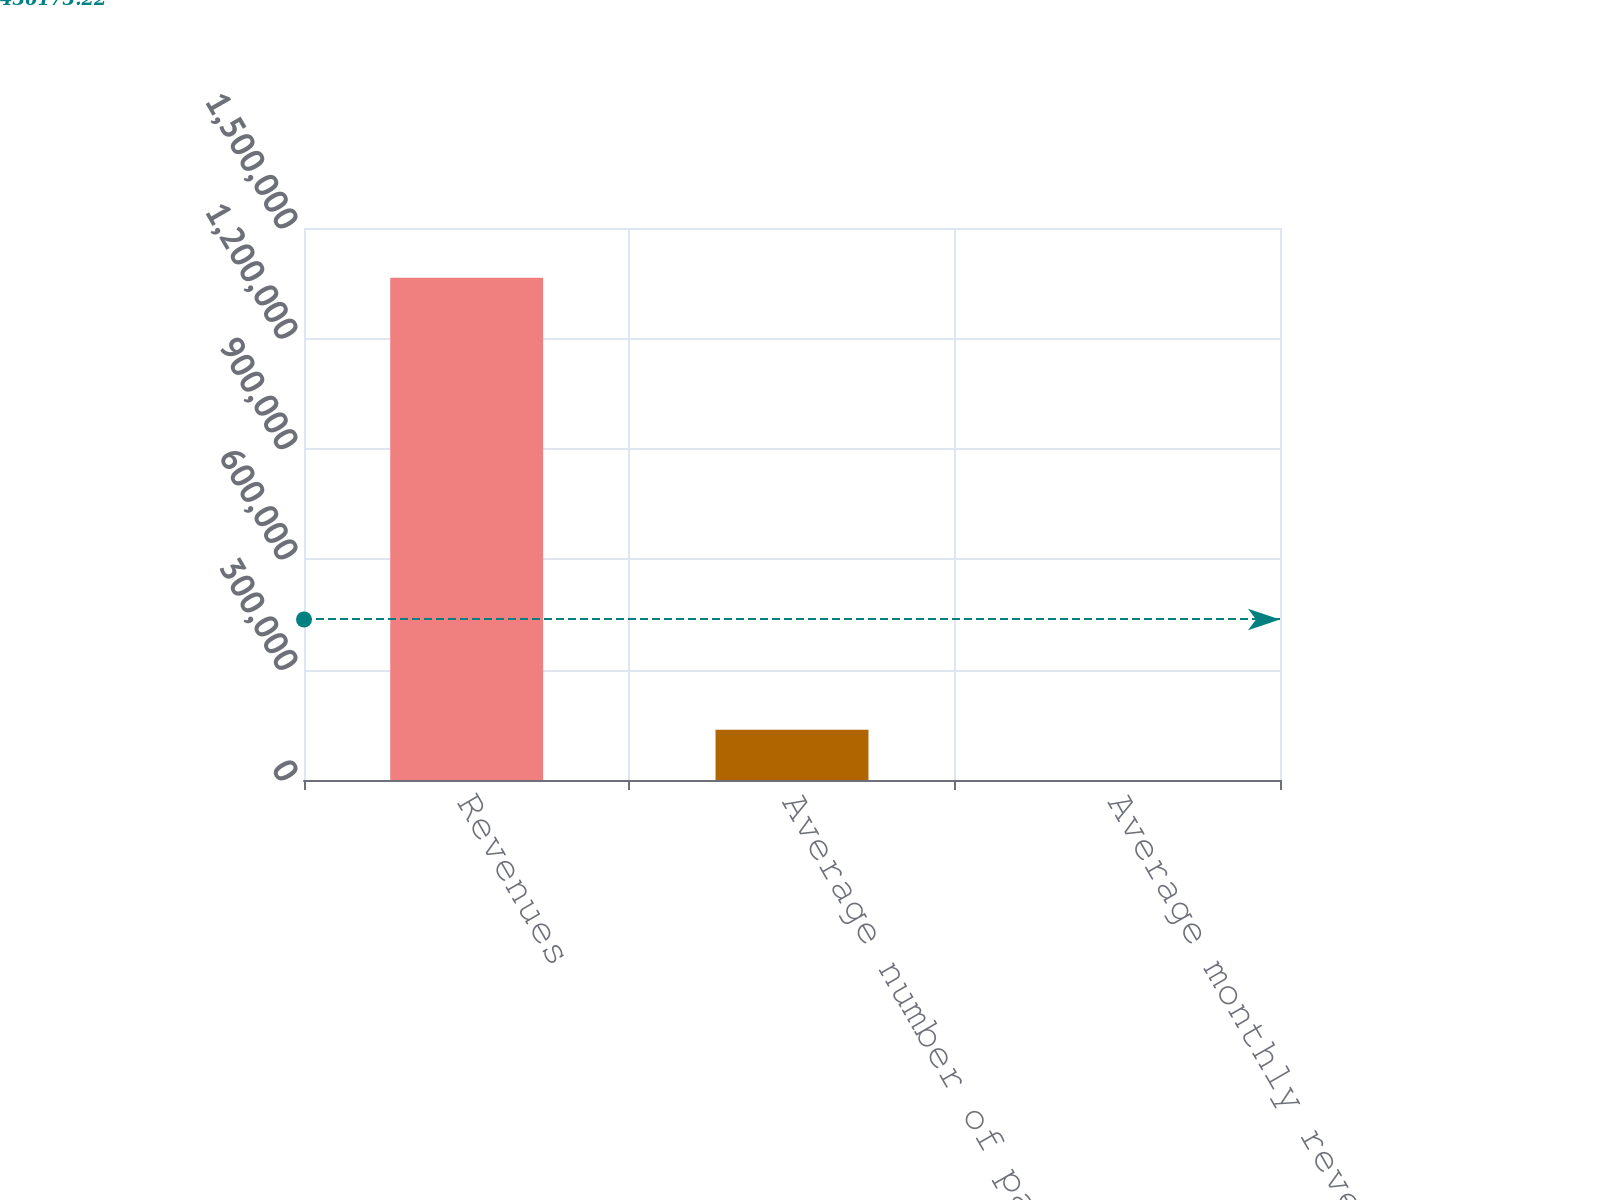<chart> <loc_0><loc_0><loc_500><loc_500><bar_chart><fcel>Revenues<fcel>Average number of paying<fcel>Average monthly revenue per<nl><fcel>1.36466e+06<fcel>136478<fcel>13.75<nl></chart> 